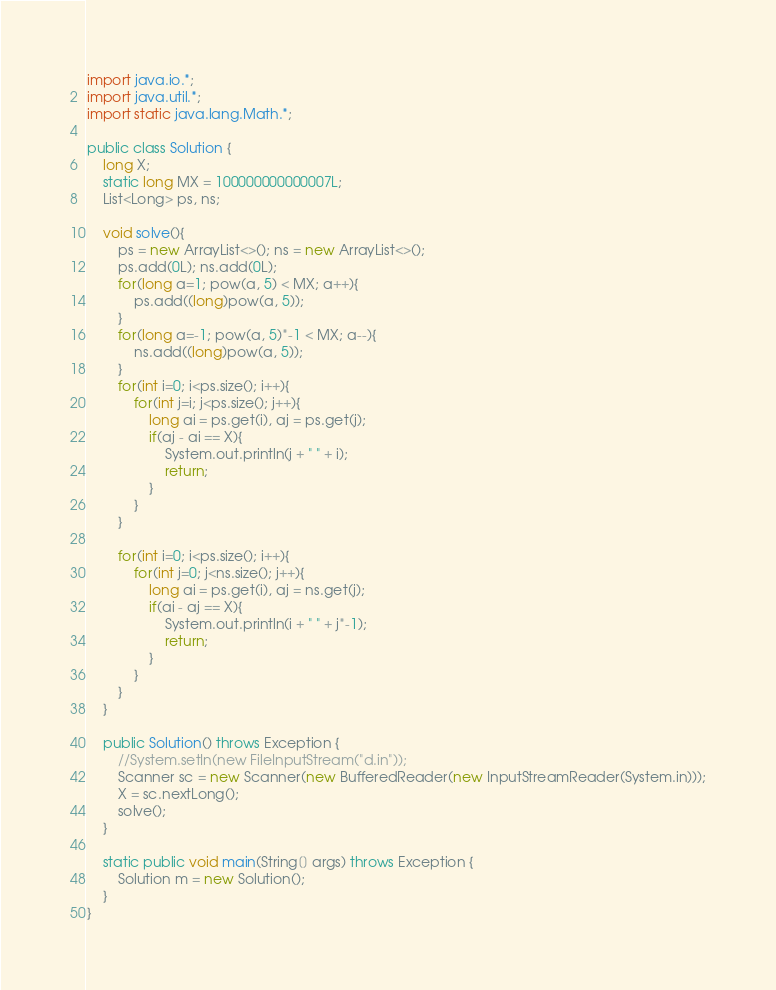<code> <loc_0><loc_0><loc_500><loc_500><_Java_>
import java.io.*;
import java.util.*;
import static java.lang.Math.*;

public class Solution {
    long X;
    static long MX = 100000000000007L;
    List<Long> ps, ns;

    void solve(){
        ps = new ArrayList<>(); ns = new ArrayList<>();
        ps.add(0L); ns.add(0L);
        for(long a=1; pow(a, 5) < MX; a++){
            ps.add((long)pow(a, 5));
        }
        for(long a=-1; pow(a, 5)*-1 < MX; a--){
            ns.add((long)pow(a, 5));
        }
        for(int i=0; i<ps.size(); i++){
            for(int j=i; j<ps.size(); j++){
                long ai = ps.get(i), aj = ps.get(j);
                if(aj - ai == X){
                    System.out.println(j + " " + i);
                    return;
                }
            }
        }

        for(int i=0; i<ps.size(); i++){
            for(int j=0; j<ns.size(); j++){
                long ai = ps.get(i), aj = ns.get(j);
                if(ai - aj == X){
                    System.out.println(i + " " + j*-1);
                    return;
                }
            }
        }
    }

    public Solution() throws Exception {
        //System.setIn(new FileInputStream("d.in"));
        Scanner sc = new Scanner(new BufferedReader(new InputStreamReader(System.in)));
        X = sc.nextLong();
        solve();
    }

    static public void main(String[] args) throws Exception {
        Solution m = new Solution();
    }
}
</code> 